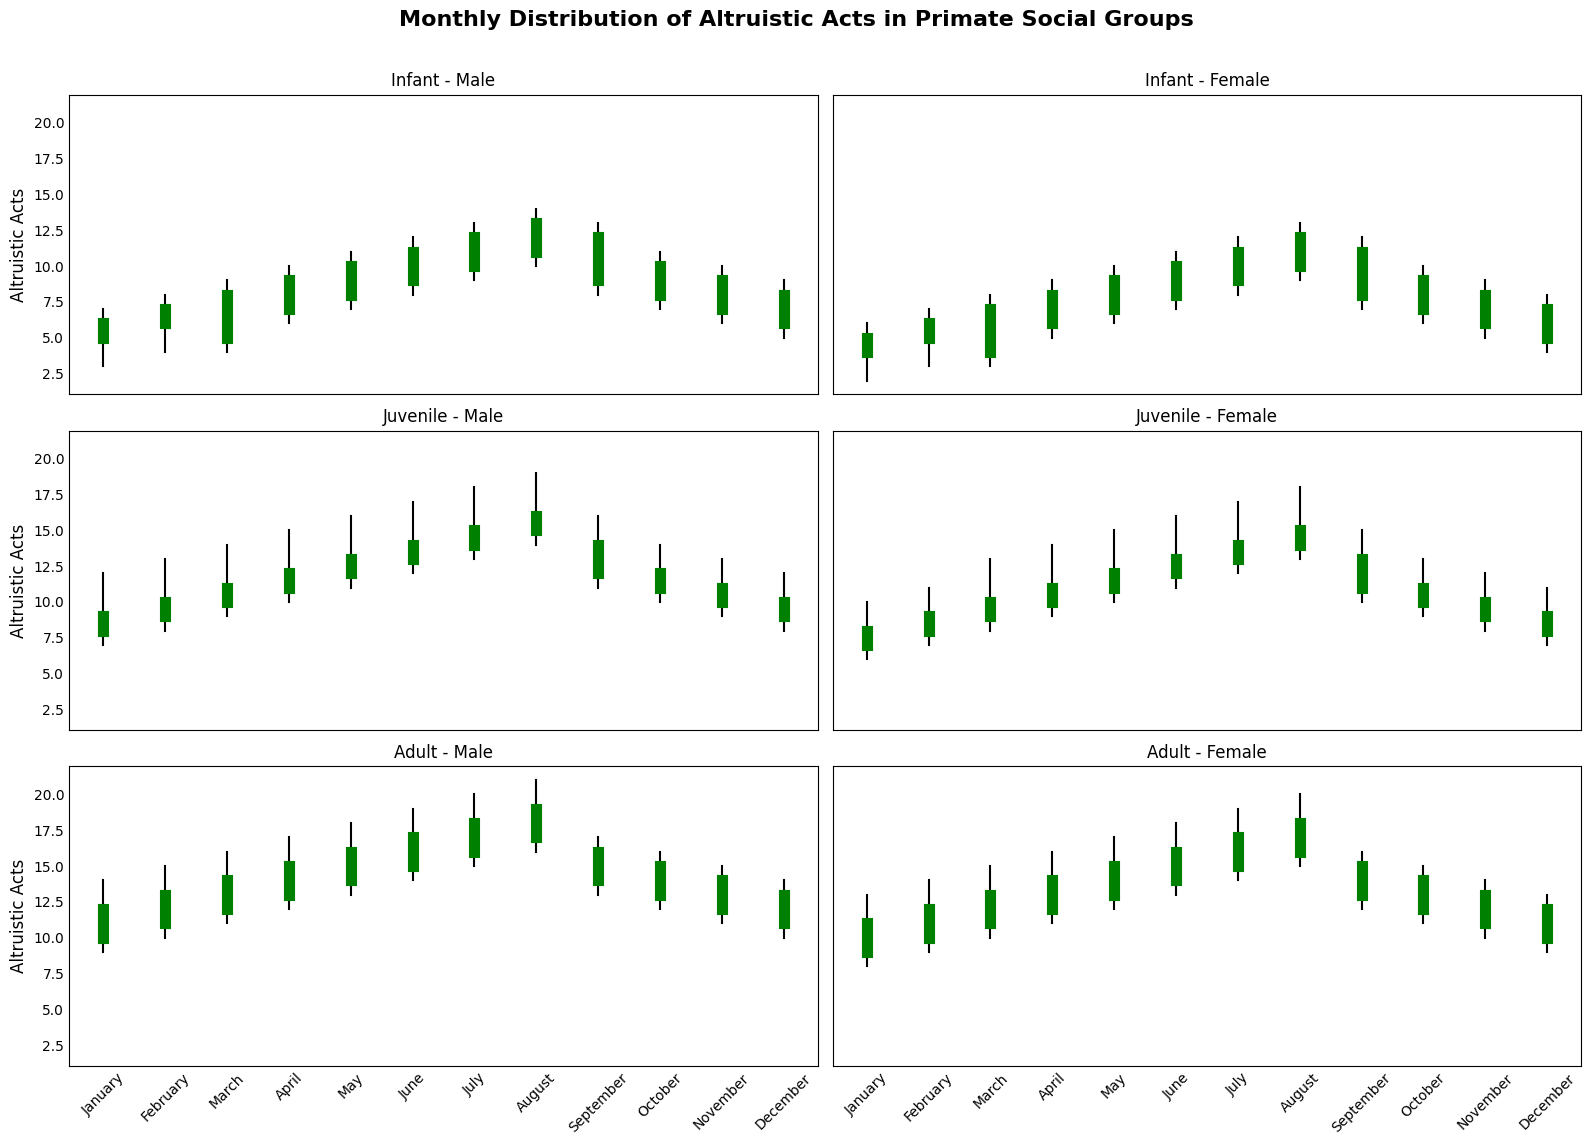Which age group shows the greatest increase in altruistic acts from January to December for males? Comparing the 'Open' values for January and December in the male category across all age groups, we calculate the increase for each:
- Infant: 6 - 5 = 1
- Juvenile: 10 - 8 = 2
- Adult: 13 - 10 = 3
Adult males show the greatest increase of 3 acts from January to December.
Answer: Adult In which month do Female Juveniles show the greatest variation between high and low values of altruistic acts? We need to find the month where the difference between the 'High' and 'Low' values is maximum for female juveniles:
- January: 10 - 6 = 4
- February: 11 - 7 = 4
- March: 13 - 8 = 5
- April: 14 - 9 = 5
- May: 15 - 10 = 5
- June: 16 - 11 = 5
- July: 17 - 12 = 5
- August: 18 - 13 = 5
- September: 15 - 10 = 5
- October: 13 - 9 = 4
- November: 12 - 8 = 4
- December: 11 - 7 = 4
The greatest variation is in March, April, May, June, July, August, and September with a difference of 5.
Answer: March, April, May, June, July, August, and September What is the average 'Close' value for Male Adults across all months? To get the average, sum the 'Close' values for each month and divide by the number of months.
- Sum: 12 (Jan) + 13 (Feb) + 14 (Mar) + 15 (Apr) + 16 (May) + 17 (Jun) + 18 (Jul) + 19 (Aug) + 16 (Sep) + 15 (Oct) + 14 (Nov) + 13 (Dec) = 182
- Total months: 12
- Average = 182 / 12 = 15.17
Answer: 15.17 Between Male and Female Infants, which group has a higher 'Close' value in July? In July, the 'Close' values are:
- Male Infants: 12
- Female Infants: 11
Males have a higher 'Close' value in July.
Answer: Male Infants Which gender and age group has the smallest difference between 'Open' and 'Close' values in any month? We need to look for the smallest difference between 'Open' and 'Close' values across all groups and months:
- Male Infant in January: 6 - 5 = 1
- This turns out to be the smallest difference, as other months and groups show higher differences.
Male Infant in January has the smallest difference.
Answer: Male Infant in January 